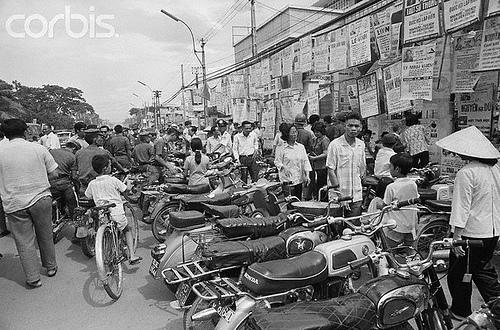How many people are wearing hats?
Give a very brief answer. 1. 